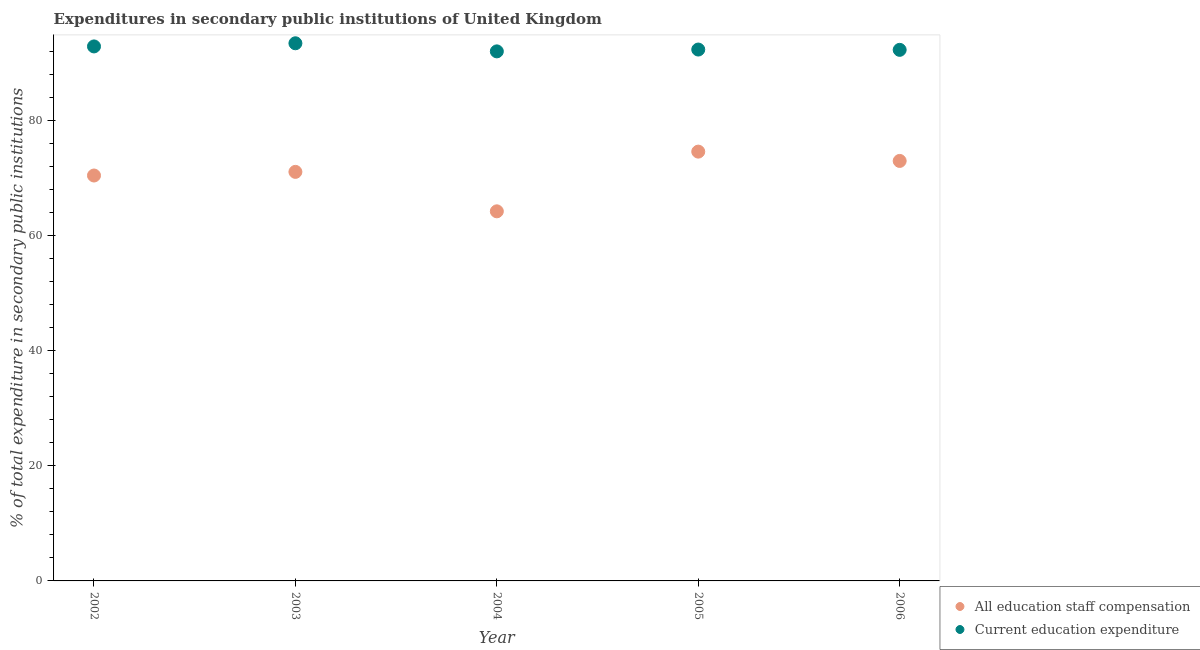How many different coloured dotlines are there?
Keep it short and to the point. 2. Is the number of dotlines equal to the number of legend labels?
Make the answer very short. Yes. What is the expenditure in education in 2003?
Your response must be concise. 93.37. Across all years, what is the maximum expenditure in staff compensation?
Your answer should be very brief. 74.55. Across all years, what is the minimum expenditure in education?
Ensure brevity in your answer.  91.96. In which year was the expenditure in education maximum?
Ensure brevity in your answer.  2003. What is the total expenditure in education in the graph?
Make the answer very short. 462.65. What is the difference between the expenditure in staff compensation in 2004 and that in 2005?
Give a very brief answer. -10.37. What is the difference between the expenditure in education in 2006 and the expenditure in staff compensation in 2002?
Your answer should be compact. 21.82. What is the average expenditure in education per year?
Ensure brevity in your answer.  92.53. In the year 2003, what is the difference between the expenditure in education and expenditure in staff compensation?
Give a very brief answer. 22.33. What is the ratio of the expenditure in staff compensation in 2002 to that in 2003?
Keep it short and to the point. 0.99. What is the difference between the highest and the second highest expenditure in staff compensation?
Offer a terse response. 1.62. What is the difference between the highest and the lowest expenditure in education?
Offer a terse response. 1.41. Is the sum of the expenditure in staff compensation in 2002 and 2003 greater than the maximum expenditure in education across all years?
Give a very brief answer. Yes. Is the expenditure in staff compensation strictly greater than the expenditure in education over the years?
Give a very brief answer. No. Are the values on the major ticks of Y-axis written in scientific E-notation?
Give a very brief answer. No. Does the graph contain any zero values?
Offer a terse response. No. Does the graph contain grids?
Offer a terse response. No. Where does the legend appear in the graph?
Your answer should be very brief. Bottom right. How many legend labels are there?
Offer a very short reply. 2. What is the title of the graph?
Your answer should be compact. Expenditures in secondary public institutions of United Kingdom. What is the label or title of the Y-axis?
Offer a terse response. % of total expenditure in secondary public institutions. What is the % of total expenditure in secondary public institutions of All education staff compensation in 2002?
Provide a short and direct response. 70.4. What is the % of total expenditure in secondary public institutions in Current education expenditure in 2002?
Keep it short and to the point. 92.82. What is the % of total expenditure in secondary public institutions in All education staff compensation in 2003?
Give a very brief answer. 71.03. What is the % of total expenditure in secondary public institutions of Current education expenditure in 2003?
Make the answer very short. 93.37. What is the % of total expenditure in secondary public institutions of All education staff compensation in 2004?
Ensure brevity in your answer.  64.18. What is the % of total expenditure in secondary public institutions of Current education expenditure in 2004?
Your answer should be very brief. 91.96. What is the % of total expenditure in secondary public institutions of All education staff compensation in 2005?
Provide a succinct answer. 74.55. What is the % of total expenditure in secondary public institutions in Current education expenditure in 2005?
Keep it short and to the point. 92.28. What is the % of total expenditure in secondary public institutions in All education staff compensation in 2006?
Provide a short and direct response. 72.93. What is the % of total expenditure in secondary public institutions of Current education expenditure in 2006?
Give a very brief answer. 92.22. Across all years, what is the maximum % of total expenditure in secondary public institutions of All education staff compensation?
Give a very brief answer. 74.55. Across all years, what is the maximum % of total expenditure in secondary public institutions in Current education expenditure?
Make the answer very short. 93.37. Across all years, what is the minimum % of total expenditure in secondary public institutions of All education staff compensation?
Your answer should be very brief. 64.18. Across all years, what is the minimum % of total expenditure in secondary public institutions of Current education expenditure?
Provide a short and direct response. 91.96. What is the total % of total expenditure in secondary public institutions in All education staff compensation in the graph?
Give a very brief answer. 353.11. What is the total % of total expenditure in secondary public institutions of Current education expenditure in the graph?
Your answer should be very brief. 462.65. What is the difference between the % of total expenditure in secondary public institutions of All education staff compensation in 2002 and that in 2003?
Ensure brevity in your answer.  -0.63. What is the difference between the % of total expenditure in secondary public institutions in Current education expenditure in 2002 and that in 2003?
Your answer should be compact. -0.55. What is the difference between the % of total expenditure in secondary public institutions in All education staff compensation in 2002 and that in 2004?
Offer a terse response. 6.22. What is the difference between the % of total expenditure in secondary public institutions in Current education expenditure in 2002 and that in 2004?
Provide a succinct answer. 0.86. What is the difference between the % of total expenditure in secondary public institutions in All education staff compensation in 2002 and that in 2005?
Provide a succinct answer. -4.15. What is the difference between the % of total expenditure in secondary public institutions in Current education expenditure in 2002 and that in 2005?
Ensure brevity in your answer.  0.54. What is the difference between the % of total expenditure in secondary public institutions in All education staff compensation in 2002 and that in 2006?
Provide a short and direct response. -2.53. What is the difference between the % of total expenditure in secondary public institutions in Current education expenditure in 2002 and that in 2006?
Your answer should be compact. 0.6. What is the difference between the % of total expenditure in secondary public institutions in All education staff compensation in 2003 and that in 2004?
Keep it short and to the point. 6.85. What is the difference between the % of total expenditure in secondary public institutions of Current education expenditure in 2003 and that in 2004?
Your response must be concise. 1.41. What is the difference between the % of total expenditure in secondary public institutions in All education staff compensation in 2003 and that in 2005?
Make the answer very short. -3.52. What is the difference between the % of total expenditure in secondary public institutions in Current education expenditure in 2003 and that in 2005?
Your answer should be compact. 1.09. What is the difference between the % of total expenditure in secondary public institutions of All education staff compensation in 2003 and that in 2006?
Your response must be concise. -1.9. What is the difference between the % of total expenditure in secondary public institutions of Current education expenditure in 2003 and that in 2006?
Provide a short and direct response. 1.14. What is the difference between the % of total expenditure in secondary public institutions in All education staff compensation in 2004 and that in 2005?
Offer a terse response. -10.37. What is the difference between the % of total expenditure in secondary public institutions of Current education expenditure in 2004 and that in 2005?
Your response must be concise. -0.32. What is the difference between the % of total expenditure in secondary public institutions of All education staff compensation in 2004 and that in 2006?
Your answer should be compact. -8.75. What is the difference between the % of total expenditure in secondary public institutions in Current education expenditure in 2004 and that in 2006?
Provide a short and direct response. -0.26. What is the difference between the % of total expenditure in secondary public institutions of All education staff compensation in 2005 and that in 2006?
Provide a short and direct response. 1.62. What is the difference between the % of total expenditure in secondary public institutions in Current education expenditure in 2005 and that in 2006?
Offer a very short reply. 0.05. What is the difference between the % of total expenditure in secondary public institutions of All education staff compensation in 2002 and the % of total expenditure in secondary public institutions of Current education expenditure in 2003?
Make the answer very short. -22.96. What is the difference between the % of total expenditure in secondary public institutions in All education staff compensation in 2002 and the % of total expenditure in secondary public institutions in Current education expenditure in 2004?
Ensure brevity in your answer.  -21.56. What is the difference between the % of total expenditure in secondary public institutions in All education staff compensation in 2002 and the % of total expenditure in secondary public institutions in Current education expenditure in 2005?
Provide a short and direct response. -21.88. What is the difference between the % of total expenditure in secondary public institutions of All education staff compensation in 2002 and the % of total expenditure in secondary public institutions of Current education expenditure in 2006?
Offer a very short reply. -21.82. What is the difference between the % of total expenditure in secondary public institutions of All education staff compensation in 2003 and the % of total expenditure in secondary public institutions of Current education expenditure in 2004?
Provide a succinct answer. -20.93. What is the difference between the % of total expenditure in secondary public institutions of All education staff compensation in 2003 and the % of total expenditure in secondary public institutions of Current education expenditure in 2005?
Offer a terse response. -21.24. What is the difference between the % of total expenditure in secondary public institutions of All education staff compensation in 2003 and the % of total expenditure in secondary public institutions of Current education expenditure in 2006?
Keep it short and to the point. -21.19. What is the difference between the % of total expenditure in secondary public institutions of All education staff compensation in 2004 and the % of total expenditure in secondary public institutions of Current education expenditure in 2005?
Provide a short and direct response. -28.09. What is the difference between the % of total expenditure in secondary public institutions in All education staff compensation in 2004 and the % of total expenditure in secondary public institutions in Current education expenditure in 2006?
Your response must be concise. -28.04. What is the difference between the % of total expenditure in secondary public institutions in All education staff compensation in 2005 and the % of total expenditure in secondary public institutions in Current education expenditure in 2006?
Ensure brevity in your answer.  -17.67. What is the average % of total expenditure in secondary public institutions in All education staff compensation per year?
Keep it short and to the point. 70.62. What is the average % of total expenditure in secondary public institutions in Current education expenditure per year?
Give a very brief answer. 92.53. In the year 2002, what is the difference between the % of total expenditure in secondary public institutions of All education staff compensation and % of total expenditure in secondary public institutions of Current education expenditure?
Keep it short and to the point. -22.42. In the year 2003, what is the difference between the % of total expenditure in secondary public institutions in All education staff compensation and % of total expenditure in secondary public institutions in Current education expenditure?
Provide a short and direct response. -22.33. In the year 2004, what is the difference between the % of total expenditure in secondary public institutions of All education staff compensation and % of total expenditure in secondary public institutions of Current education expenditure?
Provide a short and direct response. -27.78. In the year 2005, what is the difference between the % of total expenditure in secondary public institutions in All education staff compensation and % of total expenditure in secondary public institutions in Current education expenditure?
Provide a short and direct response. -17.73. In the year 2006, what is the difference between the % of total expenditure in secondary public institutions in All education staff compensation and % of total expenditure in secondary public institutions in Current education expenditure?
Ensure brevity in your answer.  -19.29. What is the ratio of the % of total expenditure in secondary public institutions in Current education expenditure in 2002 to that in 2003?
Make the answer very short. 0.99. What is the ratio of the % of total expenditure in secondary public institutions of All education staff compensation in 2002 to that in 2004?
Your answer should be compact. 1.1. What is the ratio of the % of total expenditure in secondary public institutions of Current education expenditure in 2002 to that in 2004?
Provide a short and direct response. 1.01. What is the ratio of the % of total expenditure in secondary public institutions in Current education expenditure in 2002 to that in 2005?
Ensure brevity in your answer.  1.01. What is the ratio of the % of total expenditure in secondary public institutions in All education staff compensation in 2002 to that in 2006?
Provide a short and direct response. 0.97. What is the ratio of the % of total expenditure in secondary public institutions in All education staff compensation in 2003 to that in 2004?
Make the answer very short. 1.11. What is the ratio of the % of total expenditure in secondary public institutions of Current education expenditure in 2003 to that in 2004?
Ensure brevity in your answer.  1.02. What is the ratio of the % of total expenditure in secondary public institutions of All education staff compensation in 2003 to that in 2005?
Keep it short and to the point. 0.95. What is the ratio of the % of total expenditure in secondary public institutions in Current education expenditure in 2003 to that in 2005?
Provide a succinct answer. 1.01. What is the ratio of the % of total expenditure in secondary public institutions of All education staff compensation in 2003 to that in 2006?
Keep it short and to the point. 0.97. What is the ratio of the % of total expenditure in secondary public institutions in Current education expenditure in 2003 to that in 2006?
Offer a very short reply. 1.01. What is the ratio of the % of total expenditure in secondary public institutions in All education staff compensation in 2004 to that in 2005?
Make the answer very short. 0.86. What is the ratio of the % of total expenditure in secondary public institutions of All education staff compensation in 2005 to that in 2006?
Your answer should be very brief. 1.02. What is the difference between the highest and the second highest % of total expenditure in secondary public institutions of All education staff compensation?
Make the answer very short. 1.62. What is the difference between the highest and the second highest % of total expenditure in secondary public institutions in Current education expenditure?
Keep it short and to the point. 0.55. What is the difference between the highest and the lowest % of total expenditure in secondary public institutions of All education staff compensation?
Provide a succinct answer. 10.37. What is the difference between the highest and the lowest % of total expenditure in secondary public institutions in Current education expenditure?
Provide a succinct answer. 1.41. 